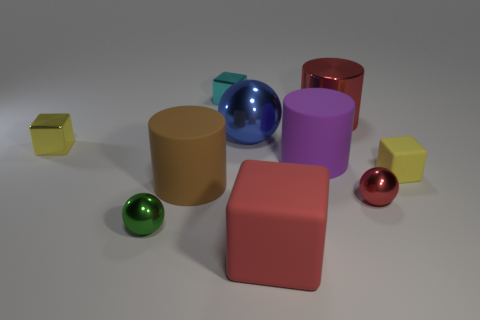Subtract all cyan shiny cubes. How many cubes are left? 3 Subtract 1 spheres. How many spheres are left? 2 Subtract all blue cylinders. How many yellow cubes are left? 2 Subtract all red blocks. How many blocks are left? 3 Subtract all cylinders. How many objects are left? 7 Subtract all large red matte blocks. Subtract all large spheres. How many objects are left? 8 Add 6 purple cylinders. How many purple cylinders are left? 7 Add 7 gray shiny things. How many gray shiny things exist? 7 Subtract 1 blue spheres. How many objects are left? 9 Subtract all green cubes. Subtract all gray balls. How many cubes are left? 4 